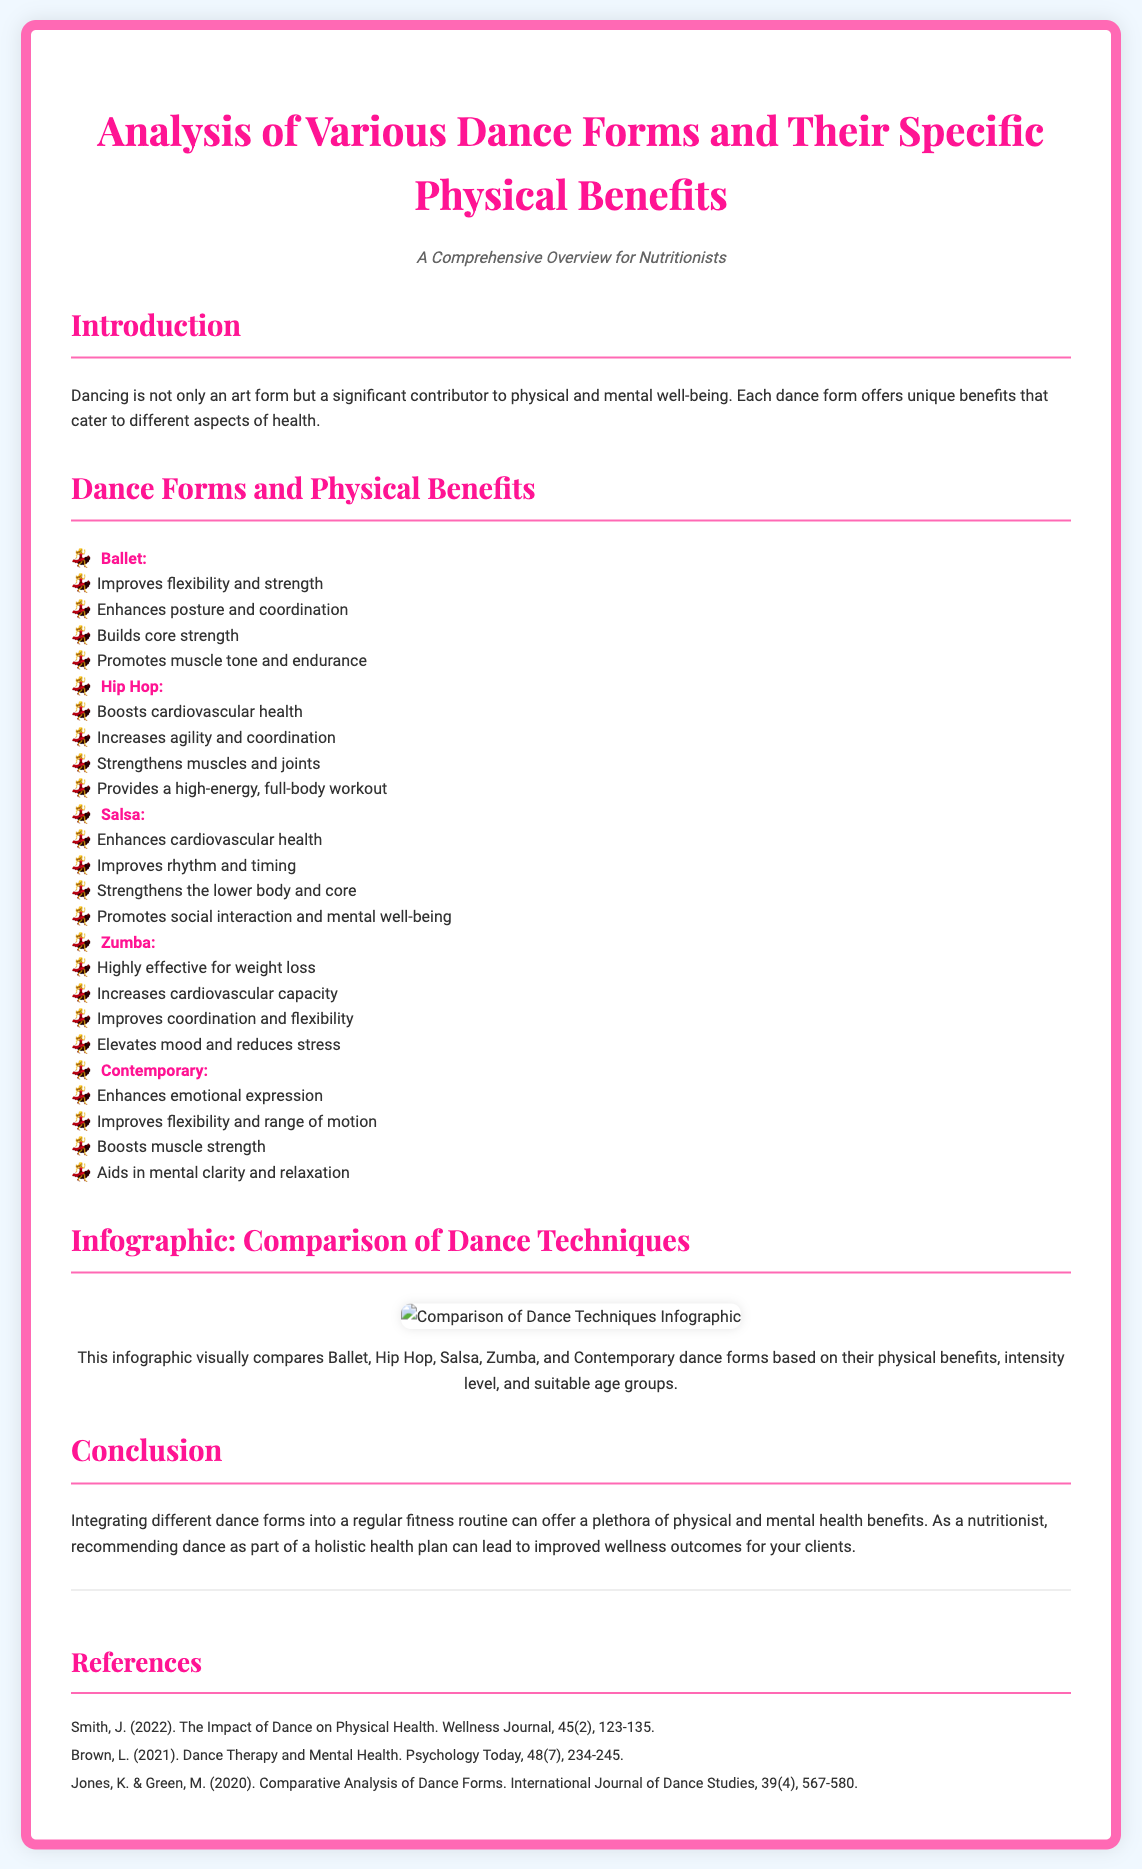What is the title of the diploma? The title is prominently displayed at the top of the document.
Answer: Analysis of Various Dance Forms and Their Specific Physical Benefits What is the subtitle of the document? The subtitle provides context for the diploma's purpose.
Answer: A Comprehensive Overview for Nutritionists How many dance forms are analyzed in the document? The document lists five specific dance forms.
Answer: Five What are the specific benefits of Ballet? The document lists several benefits of Ballet under its description.
Answer: Improves flexibility and strength, Enhances posture and coordination, Builds core strength, Promotes muscle tone and endurance Which dance form is mentioned as being effective for weight loss? The benefits of this dance form are listed in the document.
Answer: Zumba What physical benefit does Hip Hop specifically enhance? The document provides a list of benefits, including cardiovascular health.
Answer: Cardiovascular health What type of benefits does the infographic compare? The document specifies what aspects are visually compared in the infographic section.
Answer: Physical benefits, intensity level, and suitable age groups Who authored the reference regarding the impact of dance on physical health? The author's name is indicated in the references section.
Answer: Smith, J What is a benefit of Salsa listed in the document? The document specifies various benefits, including one for rhythm and timing.
Answer: Improves rhythm and timing 